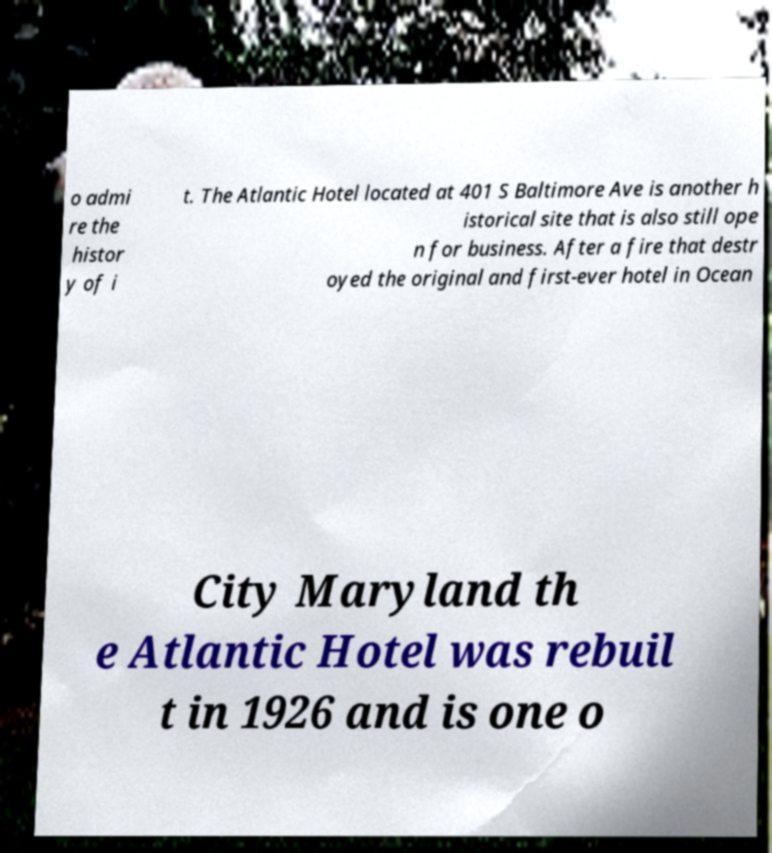There's text embedded in this image that I need extracted. Can you transcribe it verbatim? o admi re the histor y of i t. The Atlantic Hotel located at 401 S Baltimore Ave is another h istorical site that is also still ope n for business. After a fire that destr oyed the original and first-ever hotel in Ocean City Maryland th e Atlantic Hotel was rebuil t in 1926 and is one o 